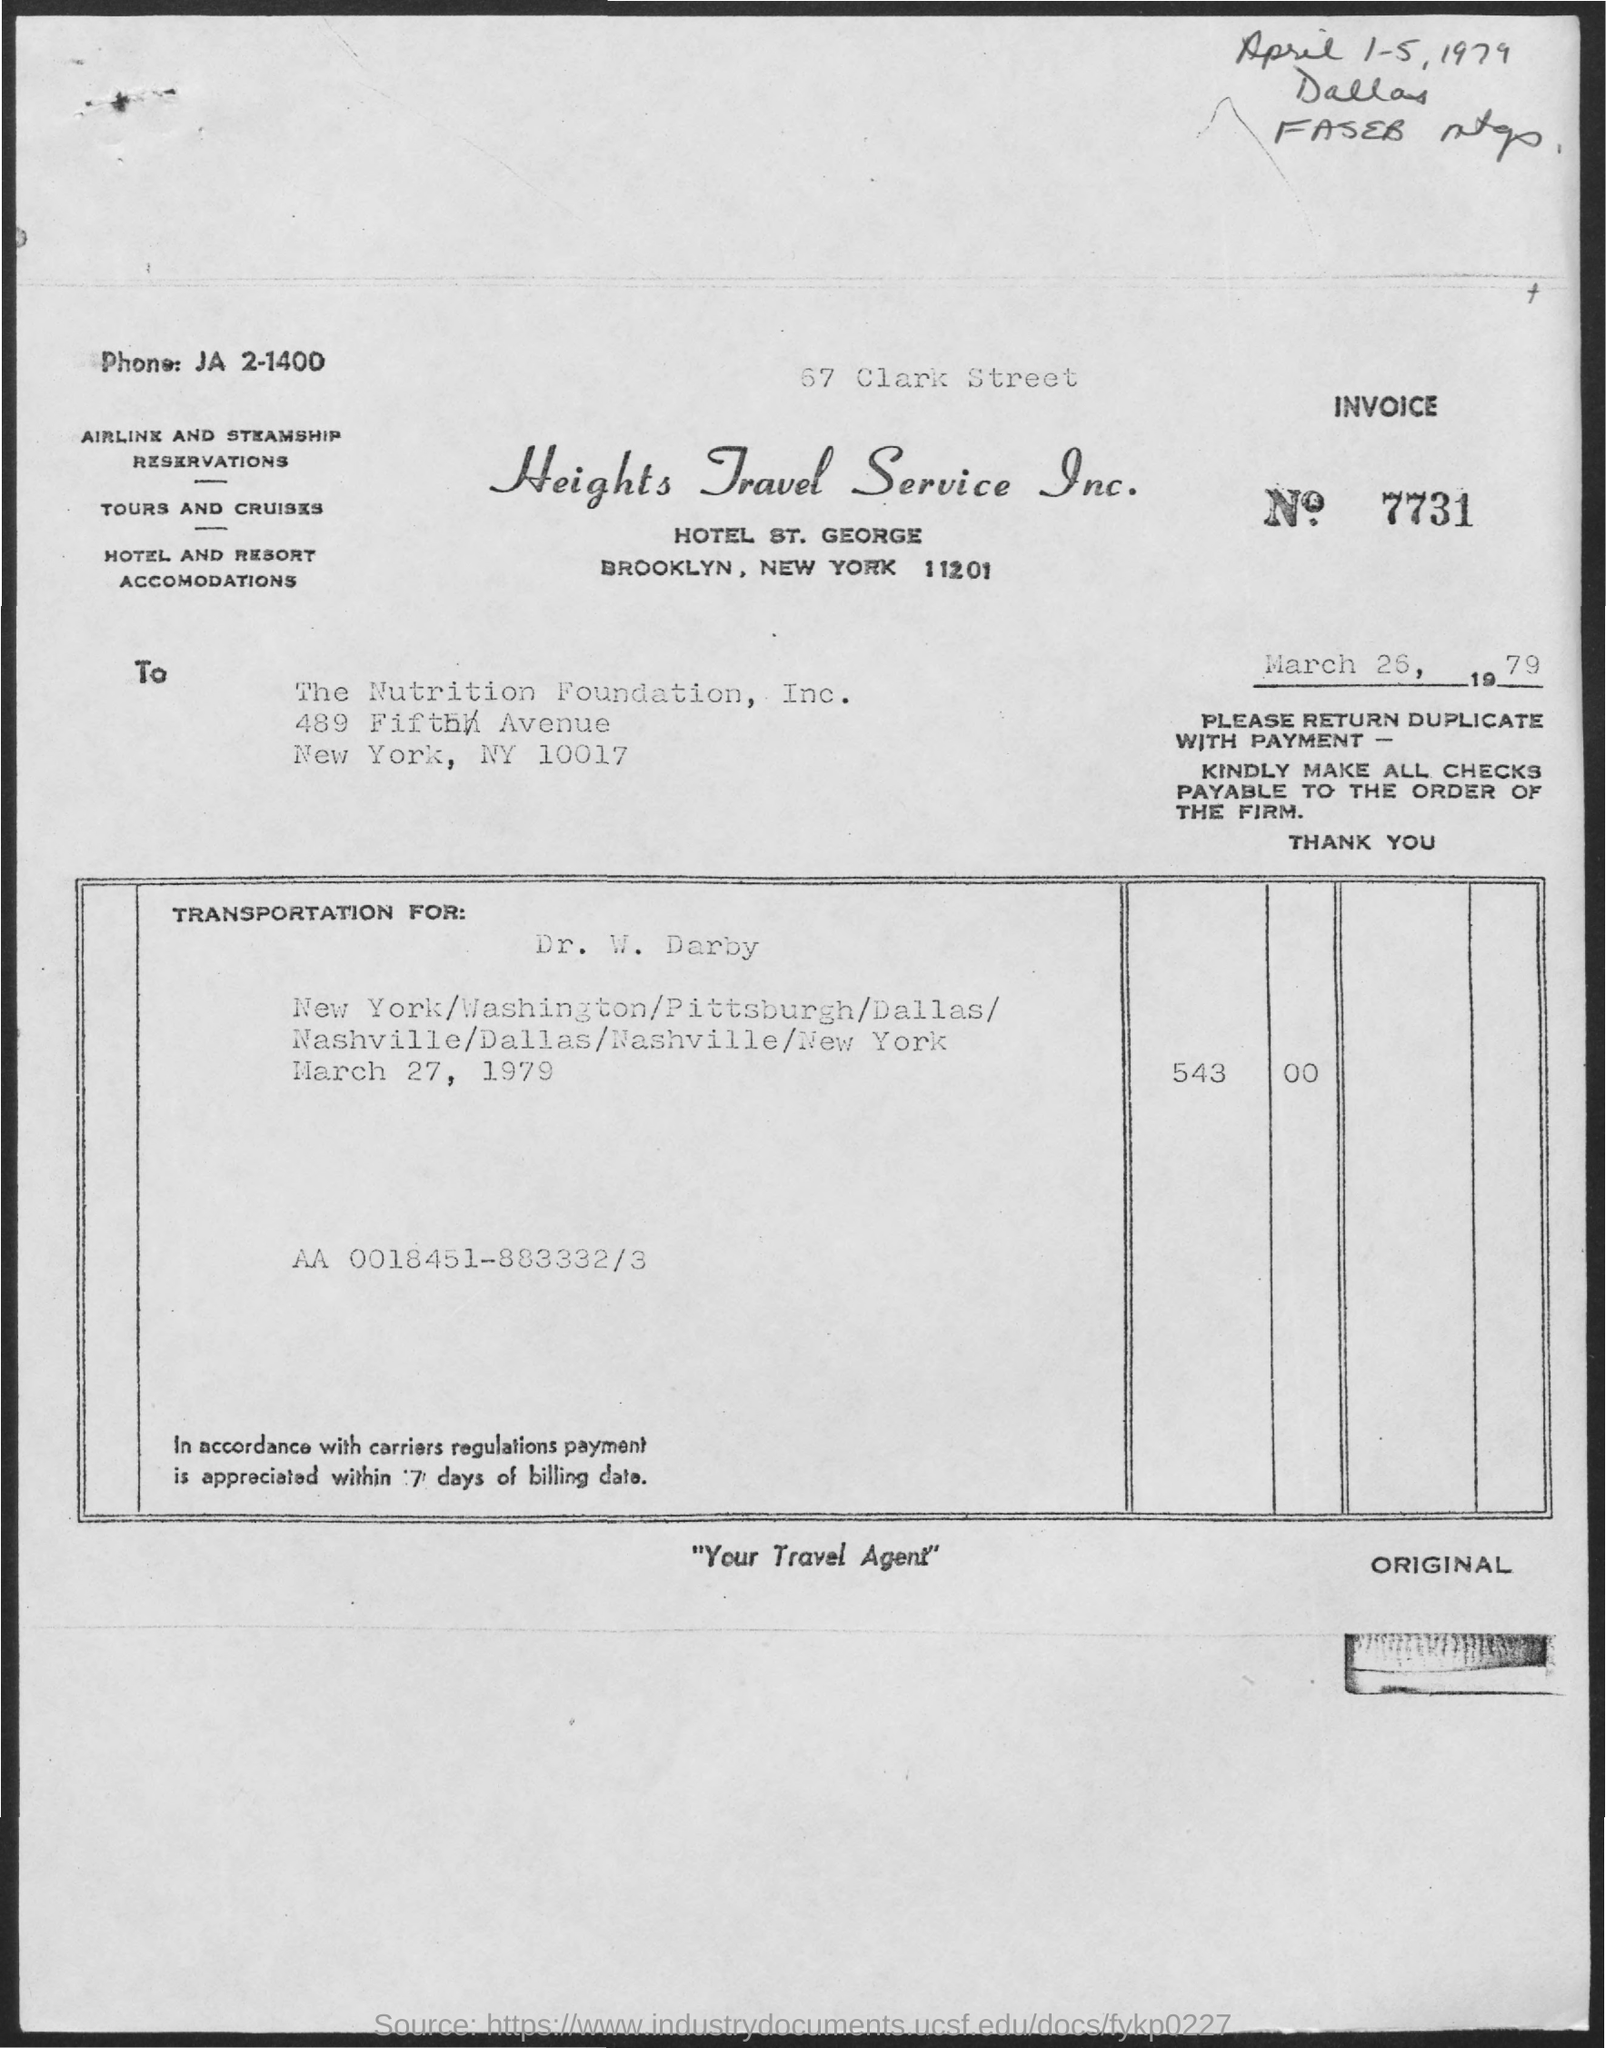Point out several critical features in this image. The INVOICE number is 7731. The phone number is JA 2-1400... 